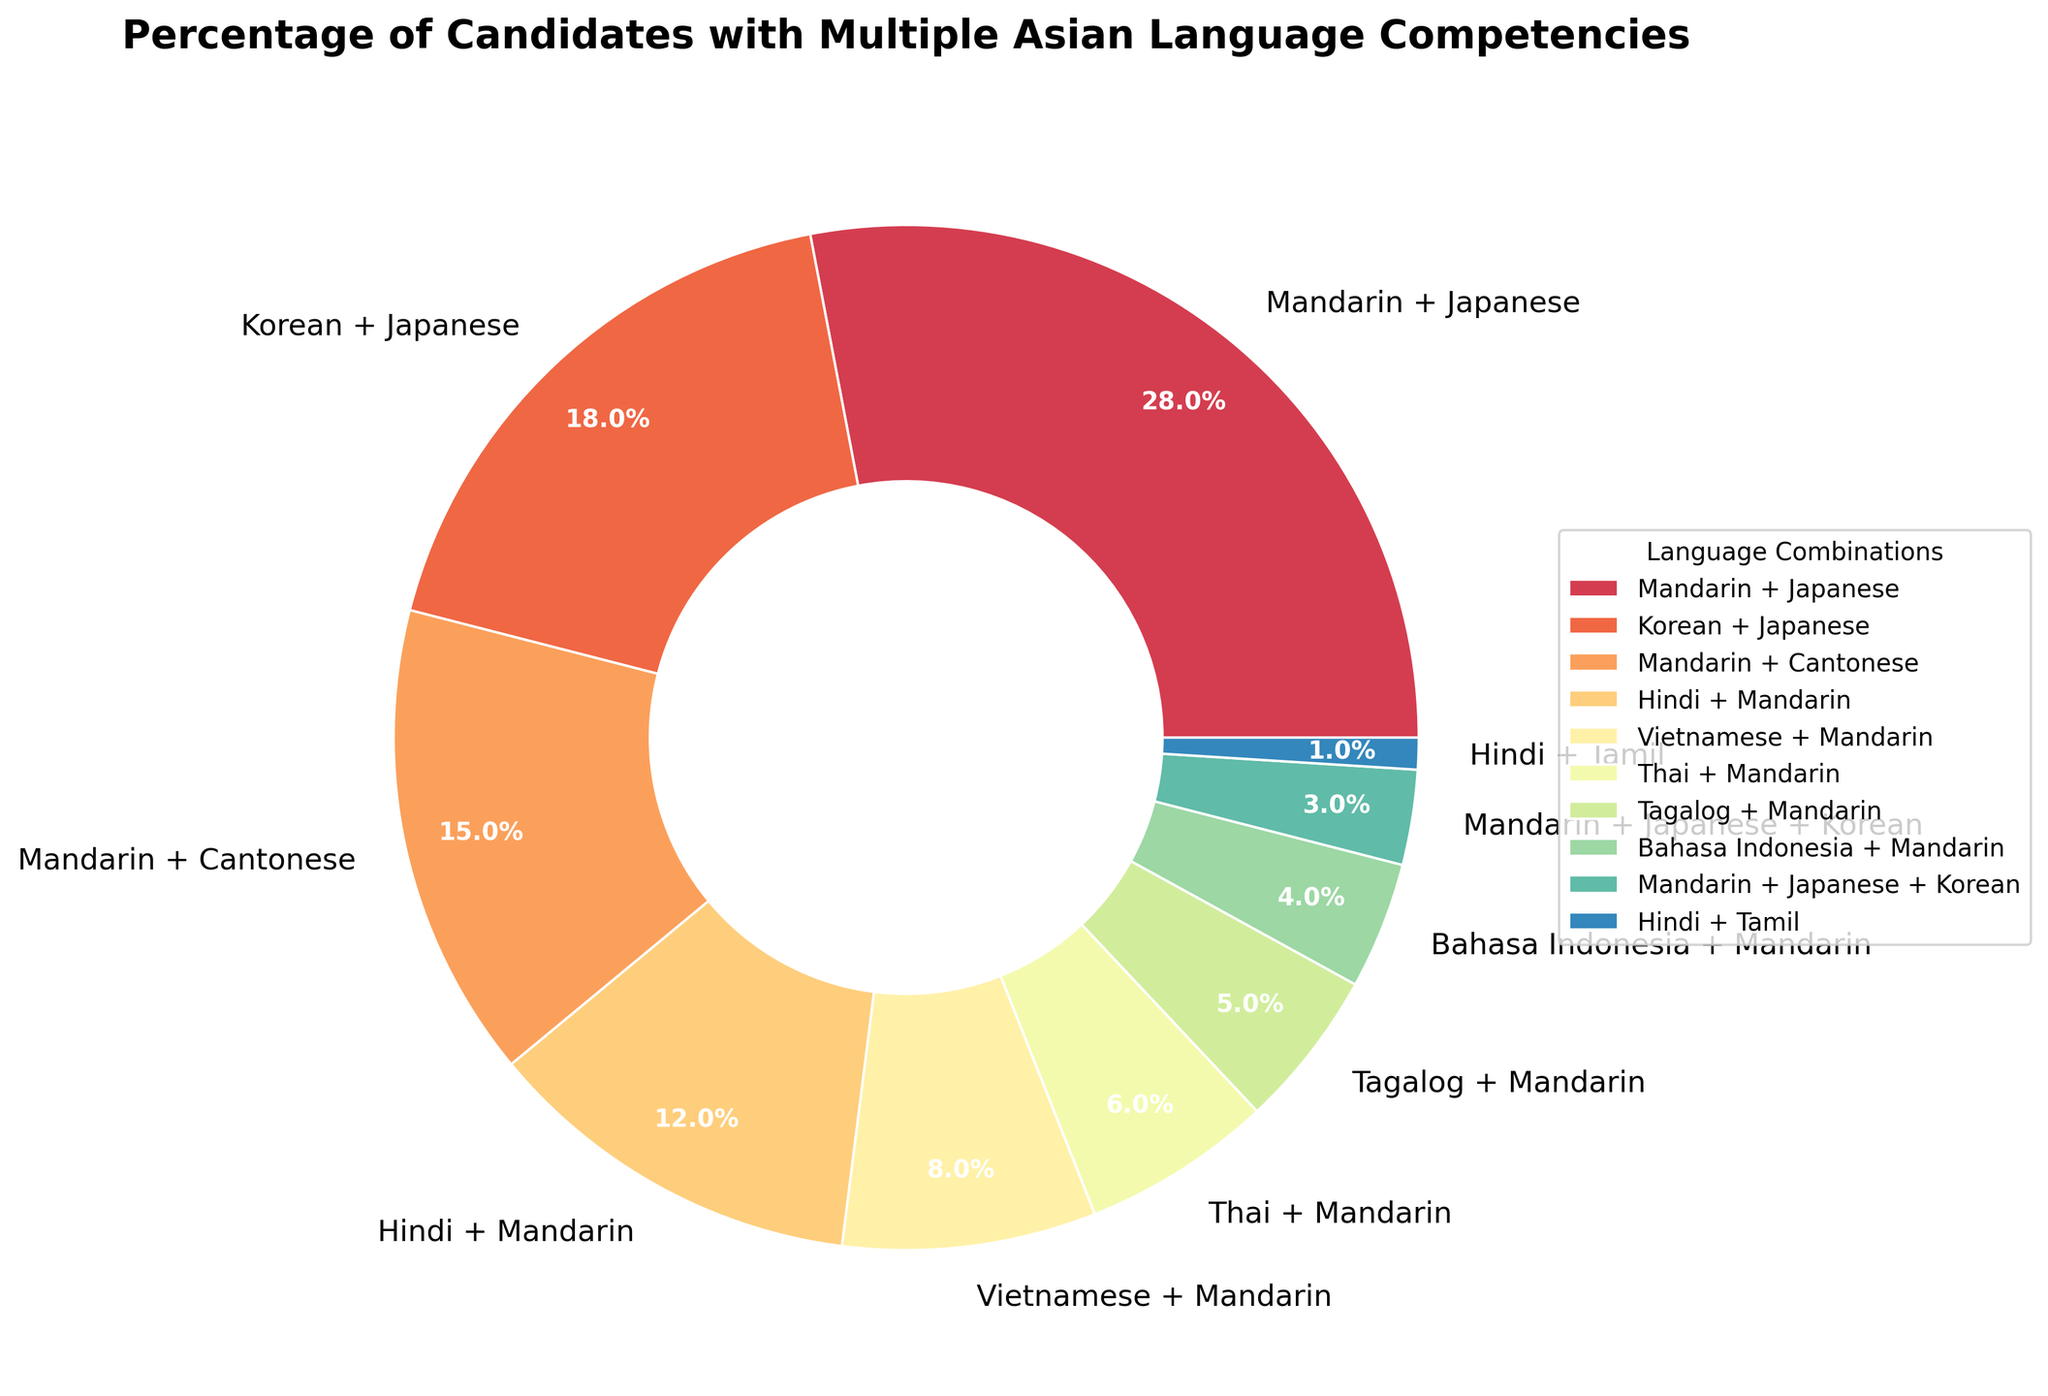What's the most common combination of languages? The pie chart shows the percentage distribution, and the largest wedge represents the most common combination. The largest wedge is labeled "Mandarin + Japanese," with 28%.
Answer: Mandarin + Japanese Which language combination has the lowest percentage of candidates? To find the least common combination, look for the smallest wedge in the pie chart. The smallest wedge is labeled "Hindi + Tamil," with 1%.
Answer: Hindi + Tamil How many combinations have more than 10% of the candidates? We need to count the wedges where the percentage is greater than 10%. The combinations are "Mandarin + Japanese," "Korean + Japanese," "Mandarin + Cantonese," and "Hindi + Mandarin." That's 4 combinations.
Answer: 4 What is the combined percentage of candidates with Mandarin in any combination? Add the percentages of all combinations containing Mandarin: "Mandarin + Japanese" (28%), "Mandarin + Cantonese" (15%), "Hindi + Mandarin" (12%), "Vietnamese + Mandarin" (8%), "Thai + Mandarin" (6%), "Tagalog + Mandarin" (5%), "Bahasa Indonesia + Mandarin" (4%), and "Mandarin + Japanese + Korean" (3%). Sum these values: 28 + 15 + 12 + 8 + 6 + 5 + 4 + 3 = 81%.
Answer: 81% Compare the proportion of candidates with "Mandarin + Japanese" to those with "Korean + Japanese." Refer to the wedges labeled "Mandarin + Japanese" and "Korean + Japanese." The percentages are 28% and 18%, respectively. "Mandarin + Japanese" has a 10% higher proportion than "Korean + Japanese."
Answer: 10% higher What is the difference in percentage between candidates with "Mandarin + Cantonese" and "Hindi + Mandarin"? The percentage for "Mandarin + Cantonese" is 15% and for "Hindi + Mandarin" is 12%. The difference is calculated by subtracting 12% from 15%, which equals 3%.
Answer: 3% What percentage of candidates know both Mandarin and a Southeast Asian language (Vietnamese, Thai, Tagalog, or Bahasa Indonesia)? Sum the percentages of these combinations: "Vietnamese + Mandarin" (8%), "Thai + Mandarin" (6%), "Tagalog + Mandarin" (5%), and "Bahasa Indonesia + Mandarin" (4%). The total is 8 + 6 + 5 + 4 = 23%.
Answer: 23% 